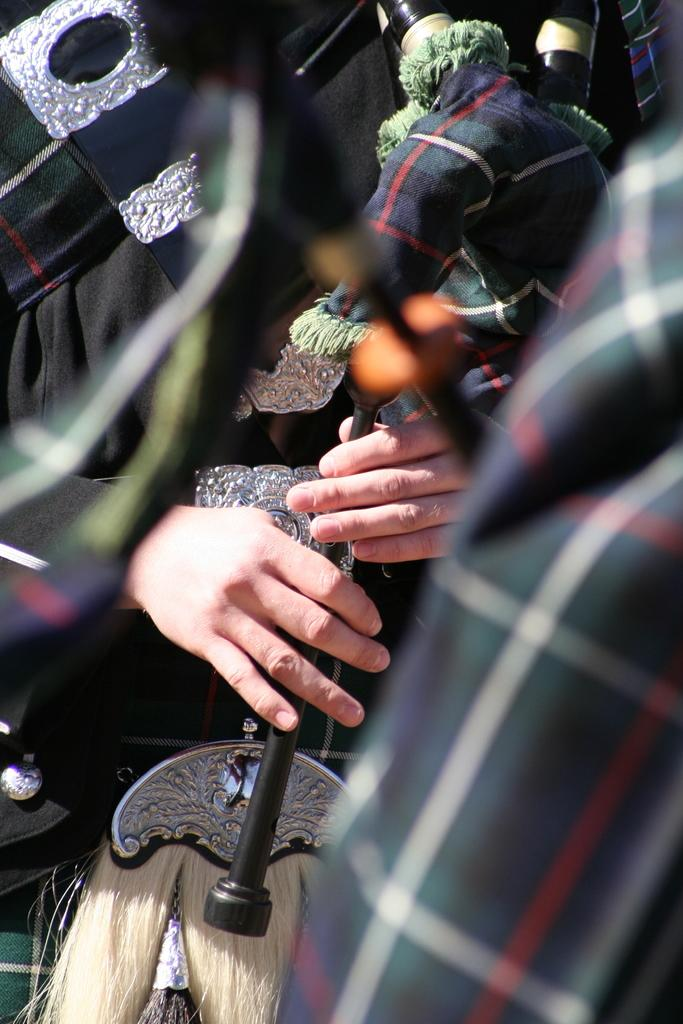What is the main subject of the image? There is a person in the image. What is the person doing in the image? The person is playing a musical instrument. What type of arithmetic problem is the person solving in the image? There is no arithmetic problem present in the image; the person is playing a musical instrument. What kind of rod can be seen in the image? There is no rod present in the image; the person is playing a musical instrument. 